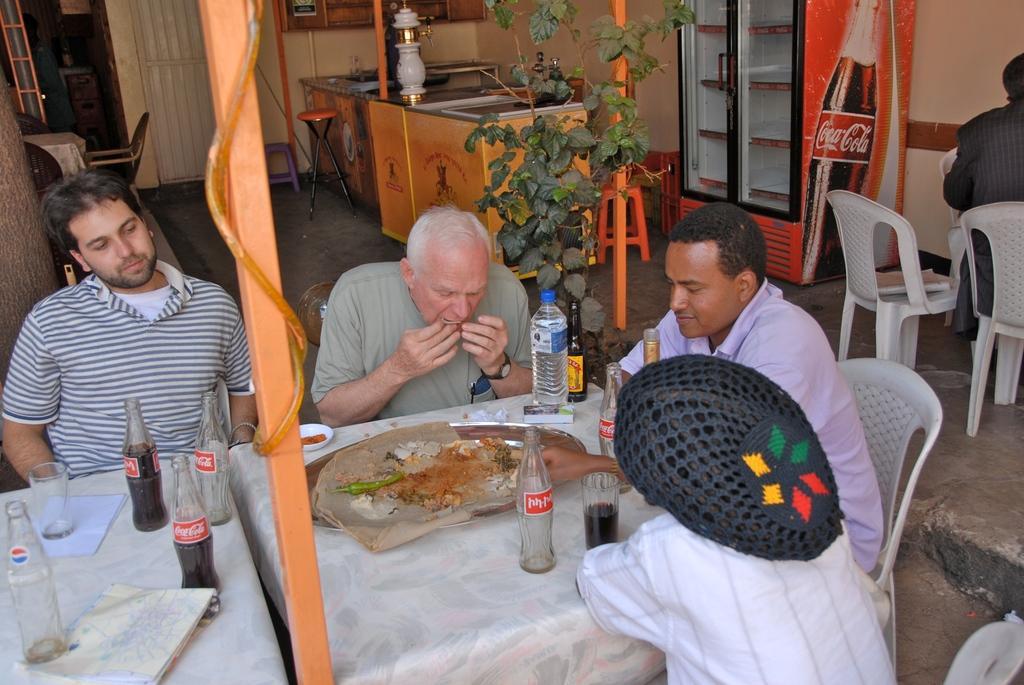Please provide a concise description of this image. In this image I can see number of people are sitting on chairs. On these tables I can see a glass and few bottles. In the background I can see a plant and a stool. 